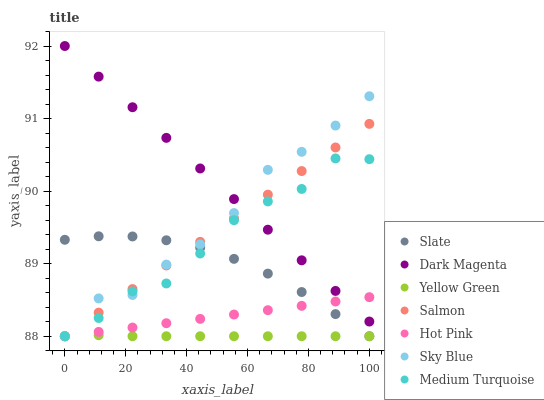Does Yellow Green have the minimum area under the curve?
Answer yes or no. Yes. Does Dark Magenta have the maximum area under the curve?
Answer yes or no. Yes. Does Slate have the minimum area under the curve?
Answer yes or no. No. Does Slate have the maximum area under the curve?
Answer yes or no. No. Is Dark Magenta the smoothest?
Answer yes or no. Yes. Is Sky Blue the roughest?
Answer yes or no. Yes. Is Slate the smoothest?
Answer yes or no. No. Is Slate the roughest?
Answer yes or no. No. Does Slate have the lowest value?
Answer yes or no. Yes. Does Dark Magenta have the highest value?
Answer yes or no. Yes. Does Slate have the highest value?
Answer yes or no. No. Is Yellow Green less than Dark Magenta?
Answer yes or no. Yes. Is Dark Magenta greater than Slate?
Answer yes or no. Yes. Does Yellow Green intersect Salmon?
Answer yes or no. Yes. Is Yellow Green less than Salmon?
Answer yes or no. No. Is Yellow Green greater than Salmon?
Answer yes or no. No. Does Yellow Green intersect Dark Magenta?
Answer yes or no. No. 